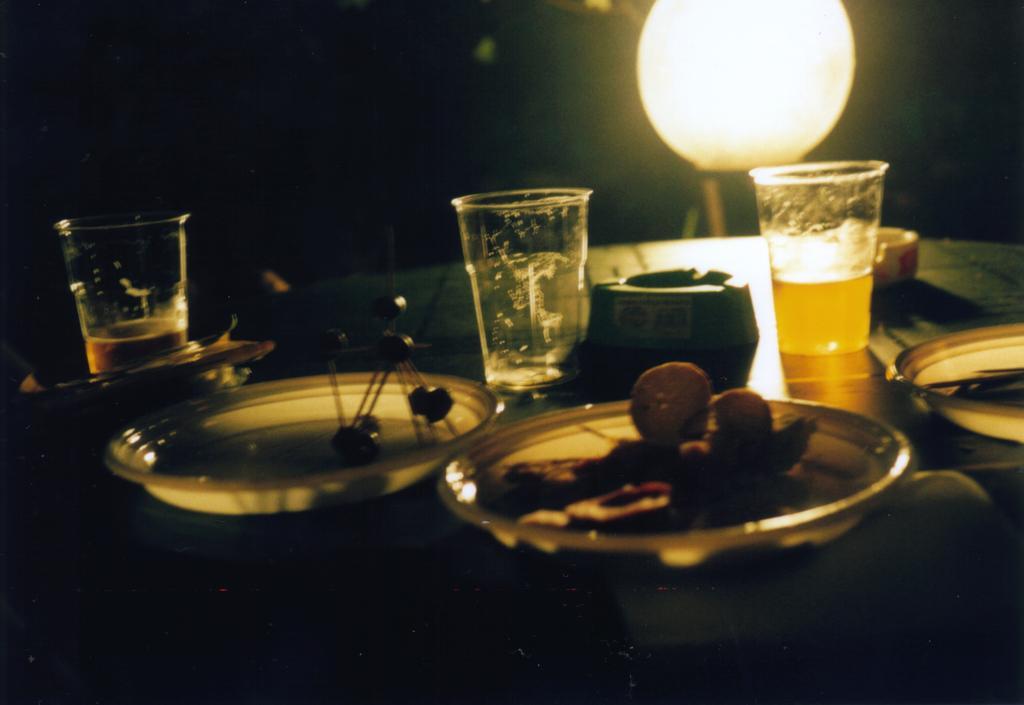Could you give a brief overview of what you see in this image? At the bottom of this image, there are plates having food items, and there are glasses and other objects placed on a table. In the background, there is light. And the background is dark in color. 